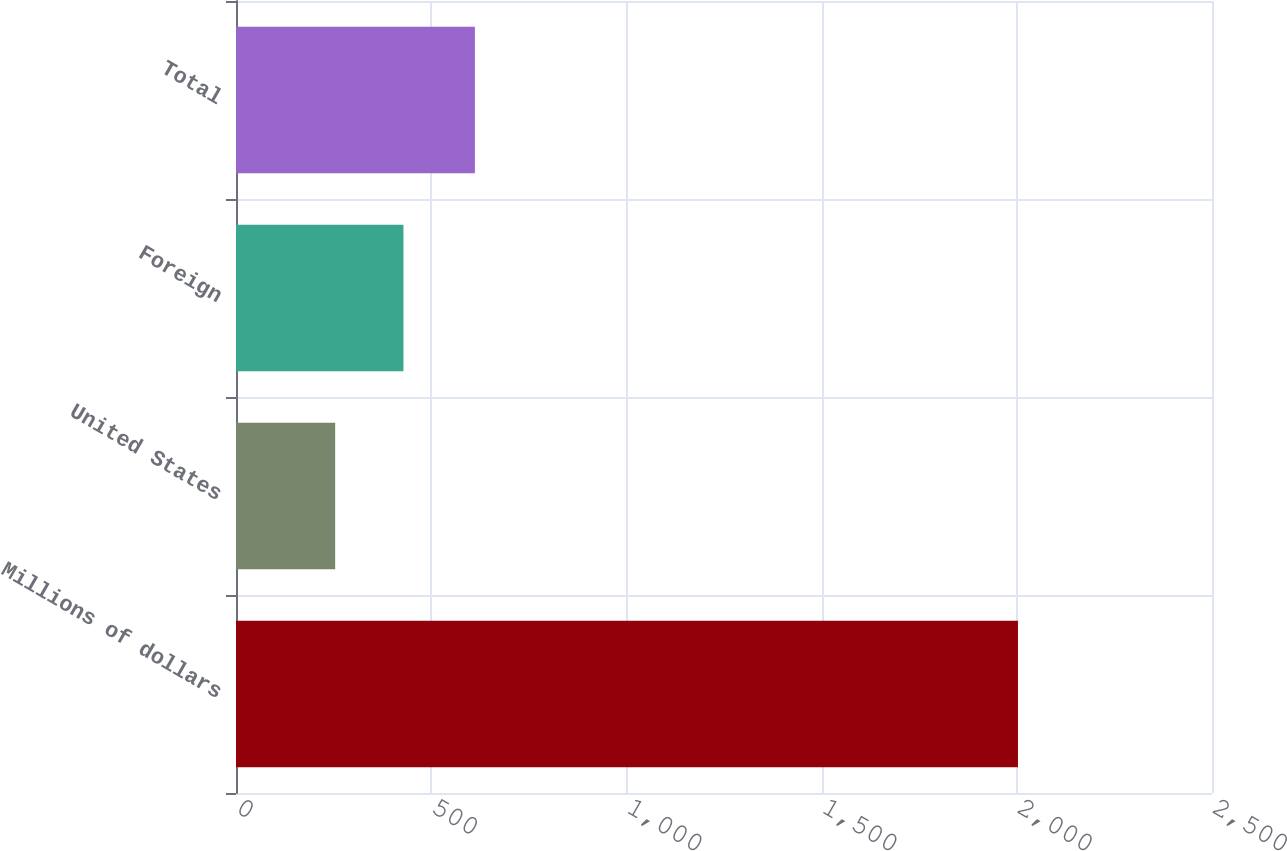Convert chart. <chart><loc_0><loc_0><loc_500><loc_500><bar_chart><fcel>Millions of dollars<fcel>United States<fcel>Foreign<fcel>Total<nl><fcel>2003<fcel>254<fcel>428.9<fcel>612<nl></chart> 